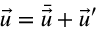Convert formula to latex. <formula><loc_0><loc_0><loc_500><loc_500>\vec { u } = \bar { \vec { u } } + \vec { u } ^ { \prime }</formula> 